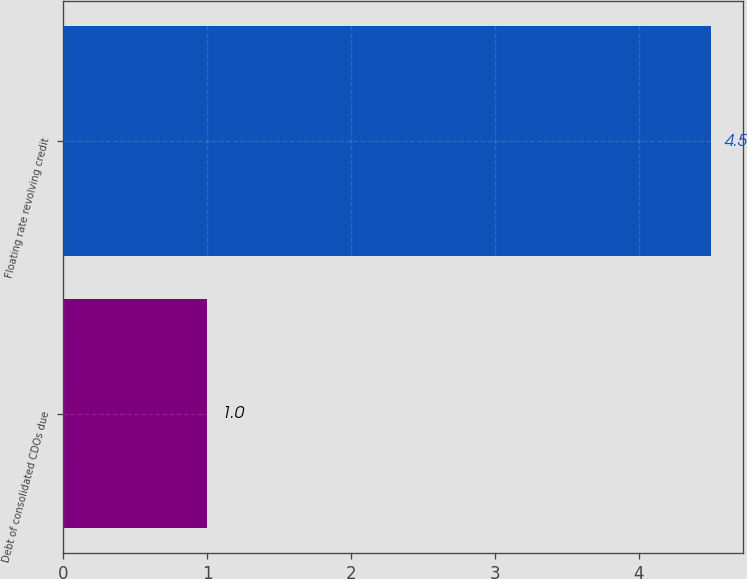Convert chart to OTSL. <chart><loc_0><loc_0><loc_500><loc_500><bar_chart><fcel>Debt of consolidated CDOs due<fcel>Floating rate revolving credit<nl><fcel>1<fcel>4.5<nl></chart> 